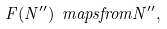Convert formula to latex. <formula><loc_0><loc_0><loc_500><loc_500>F ( N ^ { \prime \prime } ) \ m a p s f r o m N ^ { \prime \prime } ,</formula> 